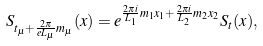Convert formula to latex. <formula><loc_0><loc_0><loc_500><loc_500>S _ { t _ { \mu } + \frac { 2 \pi } { e L _ { \mu } } m _ { \mu } } ( x ) = e ^ { \frac { 2 \pi i } { L _ { 1 } } m _ { 1 } x _ { 1 } + \frac { 2 \pi i } { L _ { 2 } } m _ { 2 } x _ { 2 } } S _ { t } ( x ) ,</formula> 